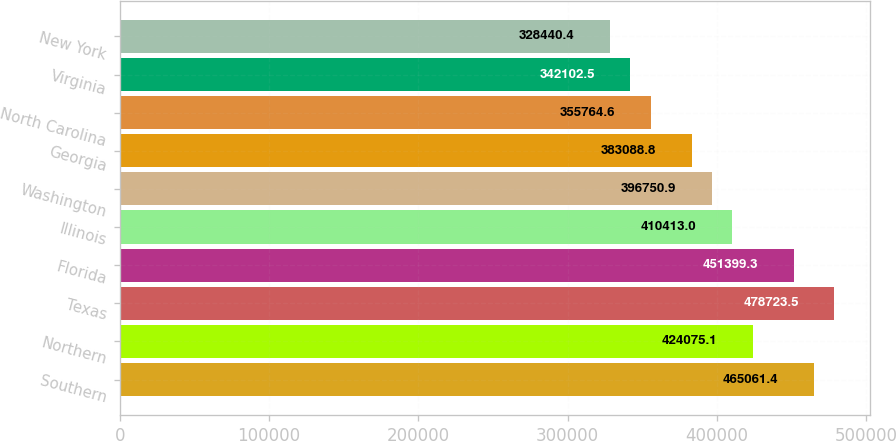Convert chart to OTSL. <chart><loc_0><loc_0><loc_500><loc_500><bar_chart><fcel>Southern<fcel>Northern<fcel>Texas<fcel>Florida<fcel>Illinois<fcel>Washington<fcel>Georgia<fcel>North Carolina<fcel>Virginia<fcel>New York<nl><fcel>465061<fcel>424075<fcel>478724<fcel>451399<fcel>410413<fcel>396751<fcel>383089<fcel>355765<fcel>342102<fcel>328440<nl></chart> 